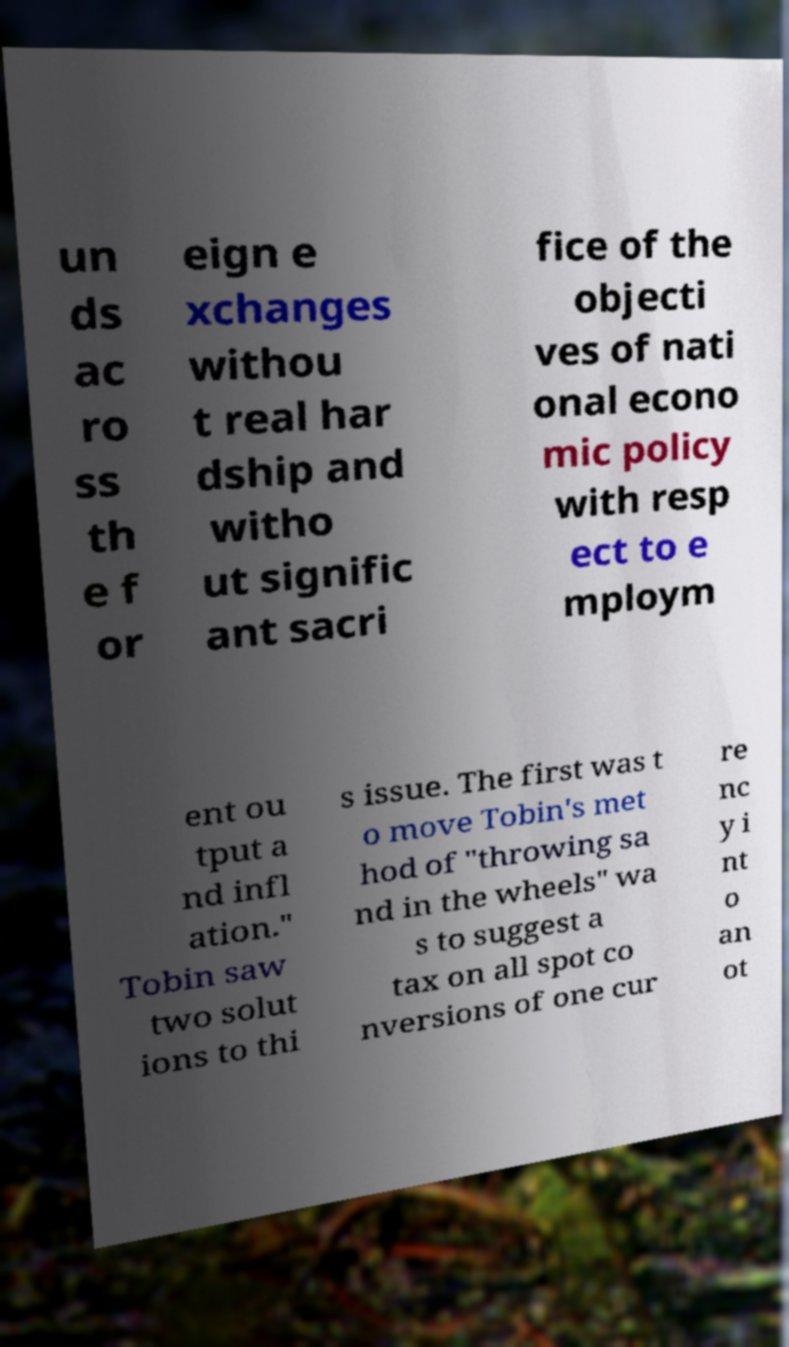I need the written content from this picture converted into text. Can you do that? un ds ac ro ss th e f or eign e xchanges withou t real har dship and witho ut signific ant sacri fice of the objecti ves of nati onal econo mic policy with resp ect to e mploym ent ou tput a nd infl ation." Tobin saw two solut ions to thi s issue. The first was t o move Tobin's met hod of "throwing sa nd in the wheels" wa s to suggest a tax on all spot co nversions of one cur re nc y i nt o an ot 